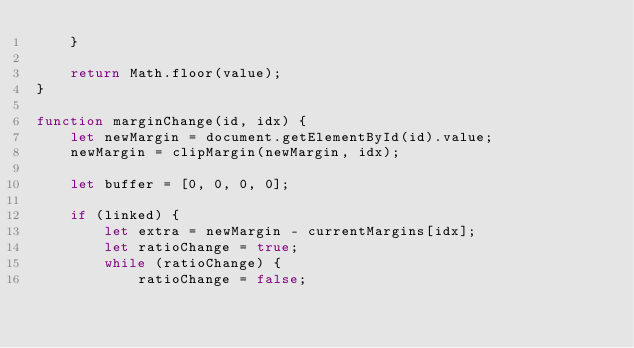Convert code to text. <code><loc_0><loc_0><loc_500><loc_500><_JavaScript_>    }

    return Math.floor(value);
}

function marginChange(id, idx) {
    let newMargin = document.getElementById(id).value;
    newMargin = clipMargin(newMargin, idx);

    let buffer = [0, 0, 0, 0];
    
    if (linked) {
        let extra = newMargin - currentMargins[idx];
        let ratioChange = true;
        while (ratioChange) {
            ratioChange = false;</code> 